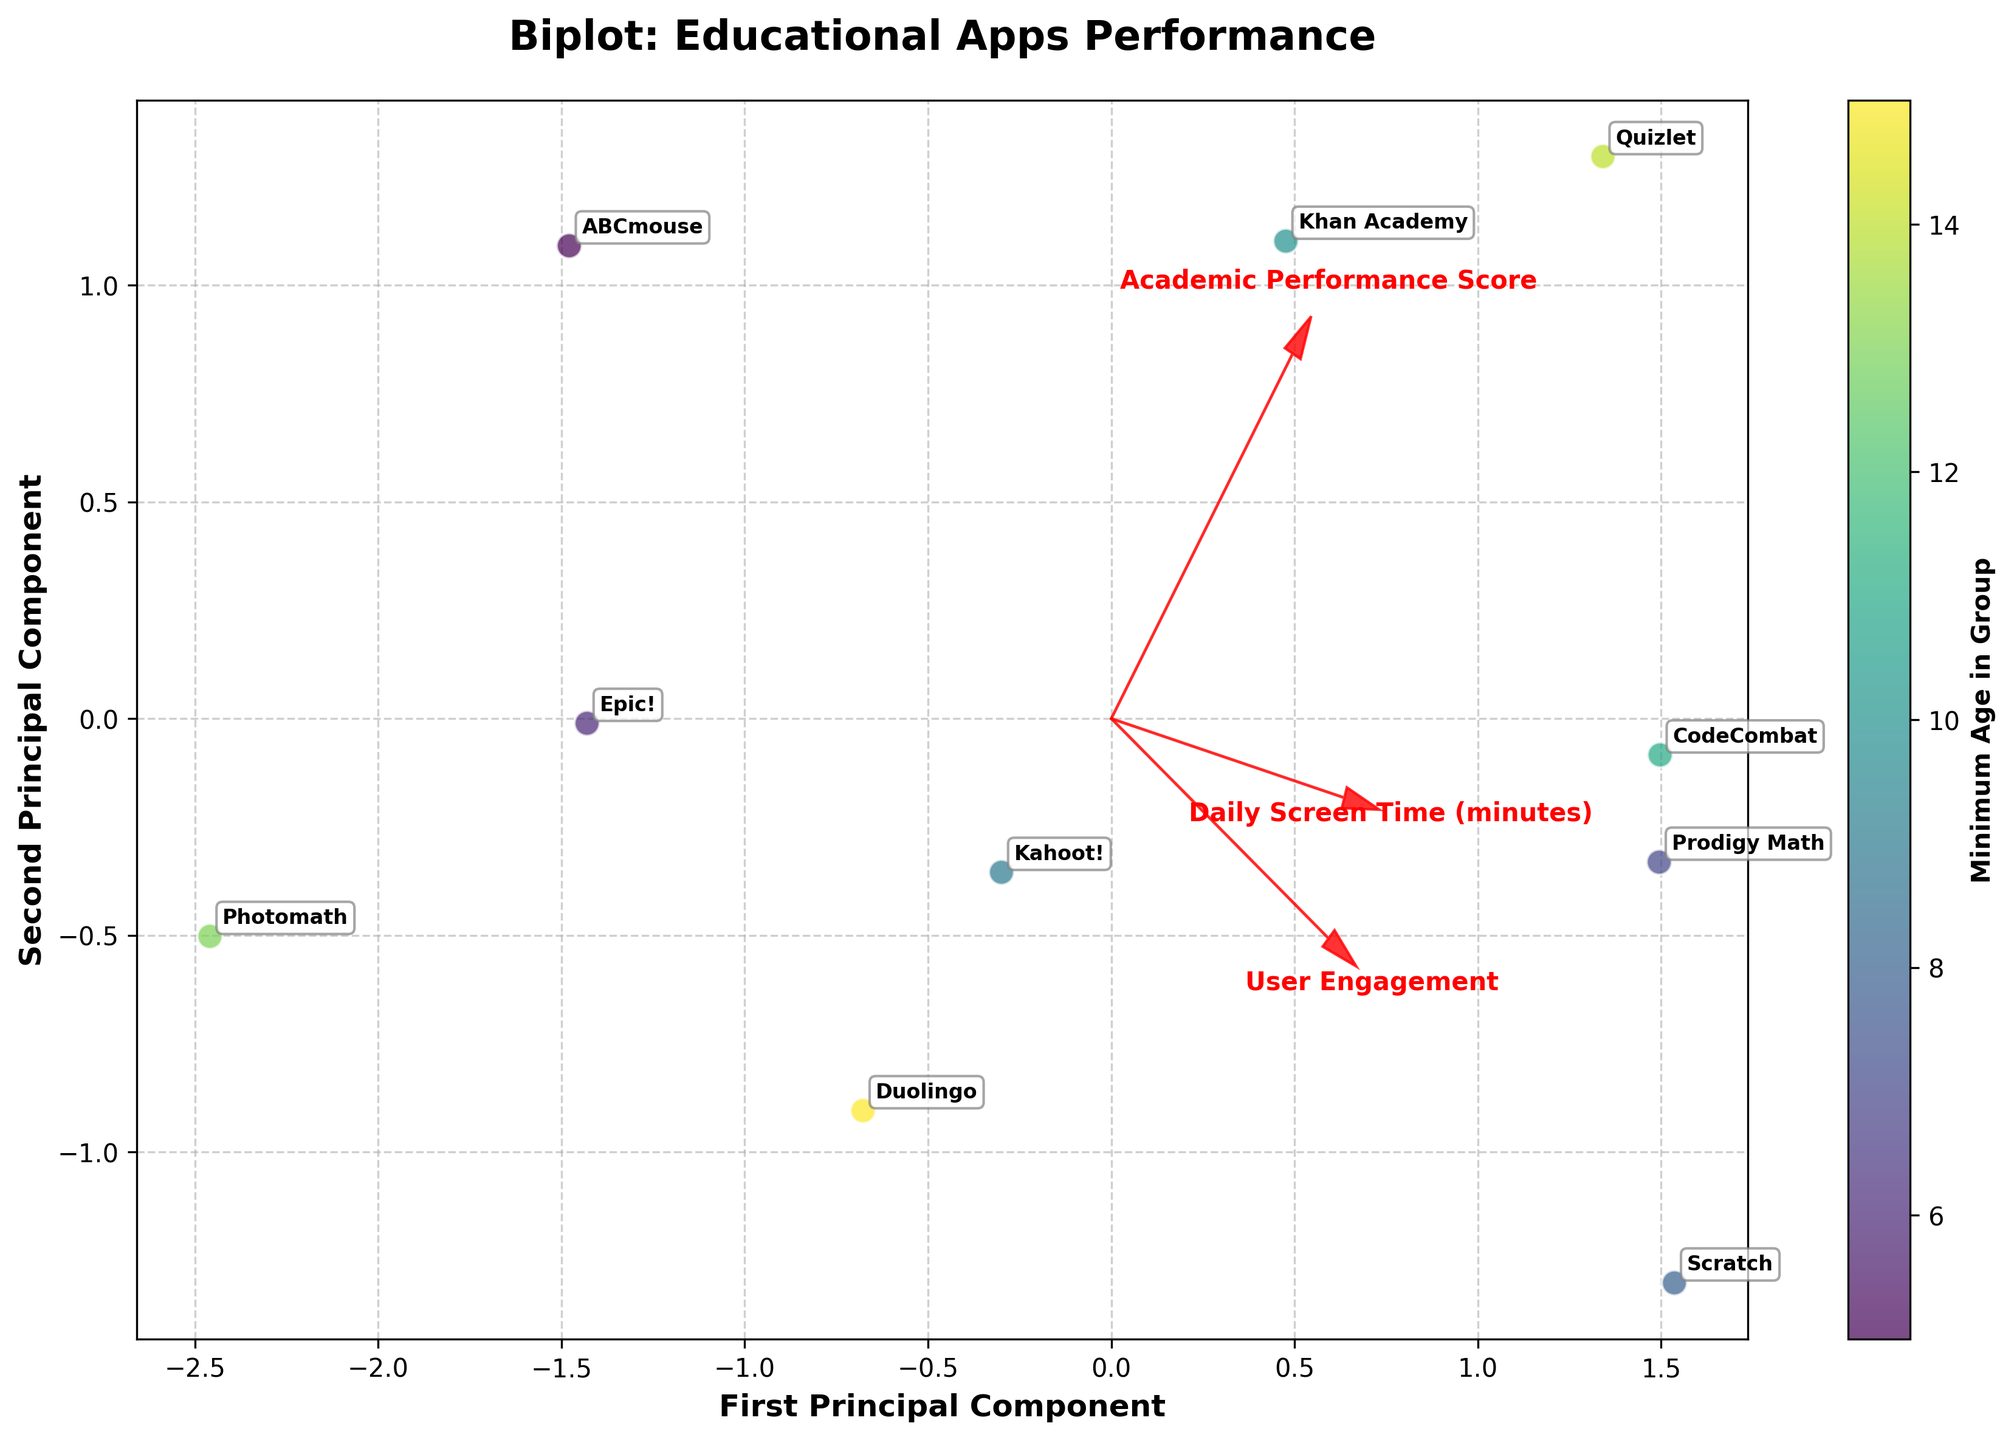Which educational app has the highest academic performance score? By looking at the data points and their labels, we identify the academic performance scores and find the app with the highest value. The highest score is observed at the label "Quizlet" with a score of 88.
Answer: Quizlet Which two educational apps are closest to each other on the biplot? To determine which apps are closest, we visually inspect the scatter plot to see the smallest distance between any two labeled points. "Epic!" and "Kahoot!" appear to be the closest.
Answer: Epic! and Kahoot! What is the relationship between user engagement and the principal components on the biplot? We examine the feature vector arrows to understand how user engagement correlates with the principal components. The arrow representing "User Engagement" shows its direction and contribution to the components. If pointing more toward the axes, it has a strong relationship with one of the principal components. It suggests user engagement has a direct relation with both principal components.
Answer: Direct relation with both components How does the age group affect the plotted position of educational apps? We look at the color gradient represented by the color bar, which encodes the minimum age in each group. Observing the distribution of min age values across the biplot reveals that apps for younger age groups are clustered differently than those for older age groups. Apps for younger age groups tend to be on one side, while older age groups are on the other.
Answer: Younger groups are separated from older ones Which feature vector is most aligned with the first principal component? The alignment of the feature vectors with the axes in which the scatter plot extends the most indicates the relationship. By looking at the feature vector arrows, we see which one extends most along the horizontal axis (the first principal component). "Daily Screen Time (minutes)" is the most aligned.
Answer: Daily Screen Time (minutes) Is there an app with both high user engagement and academic performance? From the biplot, we need to identify points where both "User Engagement" and "Academic Performance Score" are high. Observing the top-right quadrant of the biplot, "Quizlet" appears to have high values for both.
Answer: Quizlet What is the overall trend between screen time and academic performance among the apps? By examining the direction and magnitude of the arrows for "Daily Screen Time (minutes)" and "Academic Performance Score," we can infer the trend. "Daily Screen Time (minutes)" aligns positively with academic performance, suggesting a trend of higher screen time correlating with better performance.
Answer: Positive correlation Which app is an outlier based on PCA components? An outlier will be a point that stands far from the cluster of other data points on the biplot. "Scratch" seems to be an outlier as it is distanced from the other points.
Answer: Scratch What age group benefits the most from using Quizlet based on the PCA biplot? By looking at the color coding and the labels, we can determine the age range most associated with "Quizlet." It appears Quizlet is associated with ages 14-18, based on its position and color coding.
Answer: 14-18 